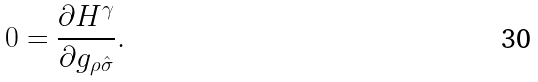<formula> <loc_0><loc_0><loc_500><loc_500>0 = \frac { \partial H ^ { \gamma } } { \partial g _ { \rho \hat { \sigma } } } .</formula> 